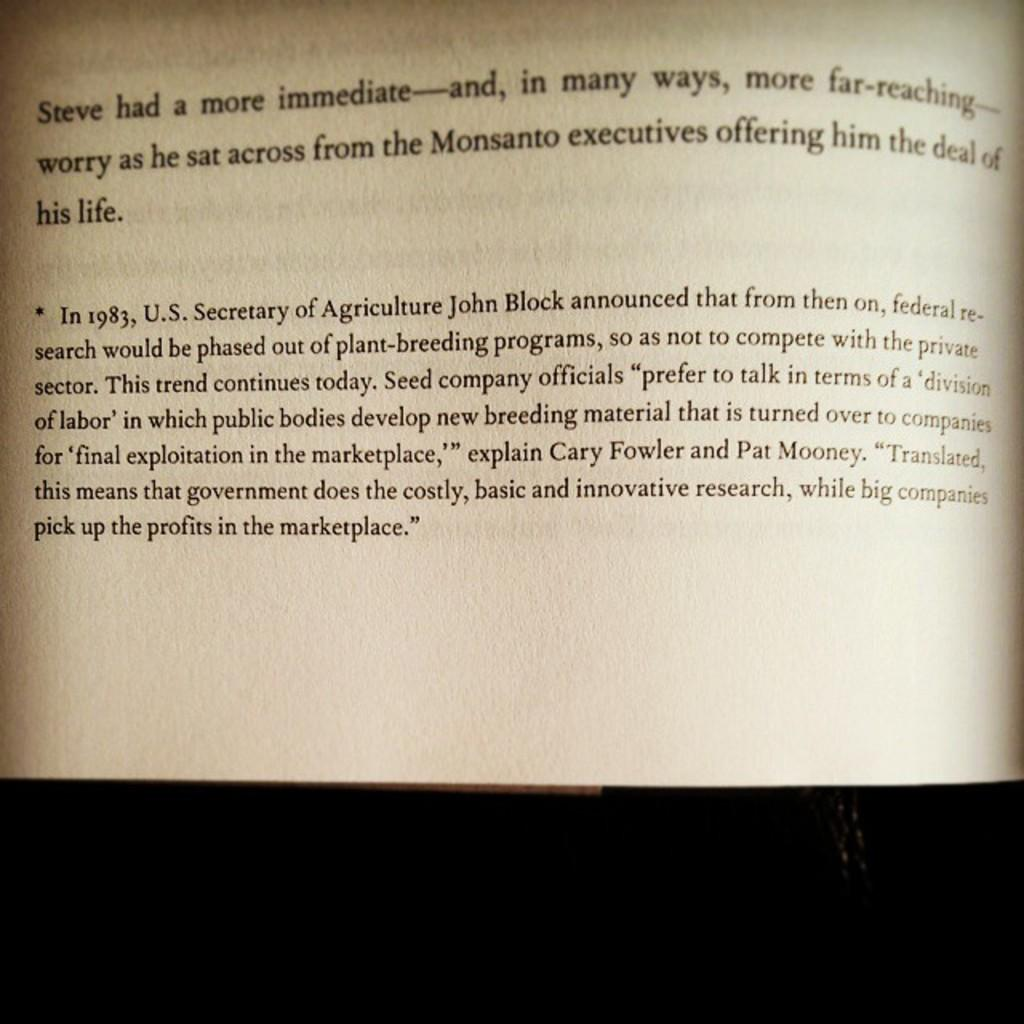<image>
Create a compact narrative representing the image presented. A book is open to a page discussing John Block and agriculture. 